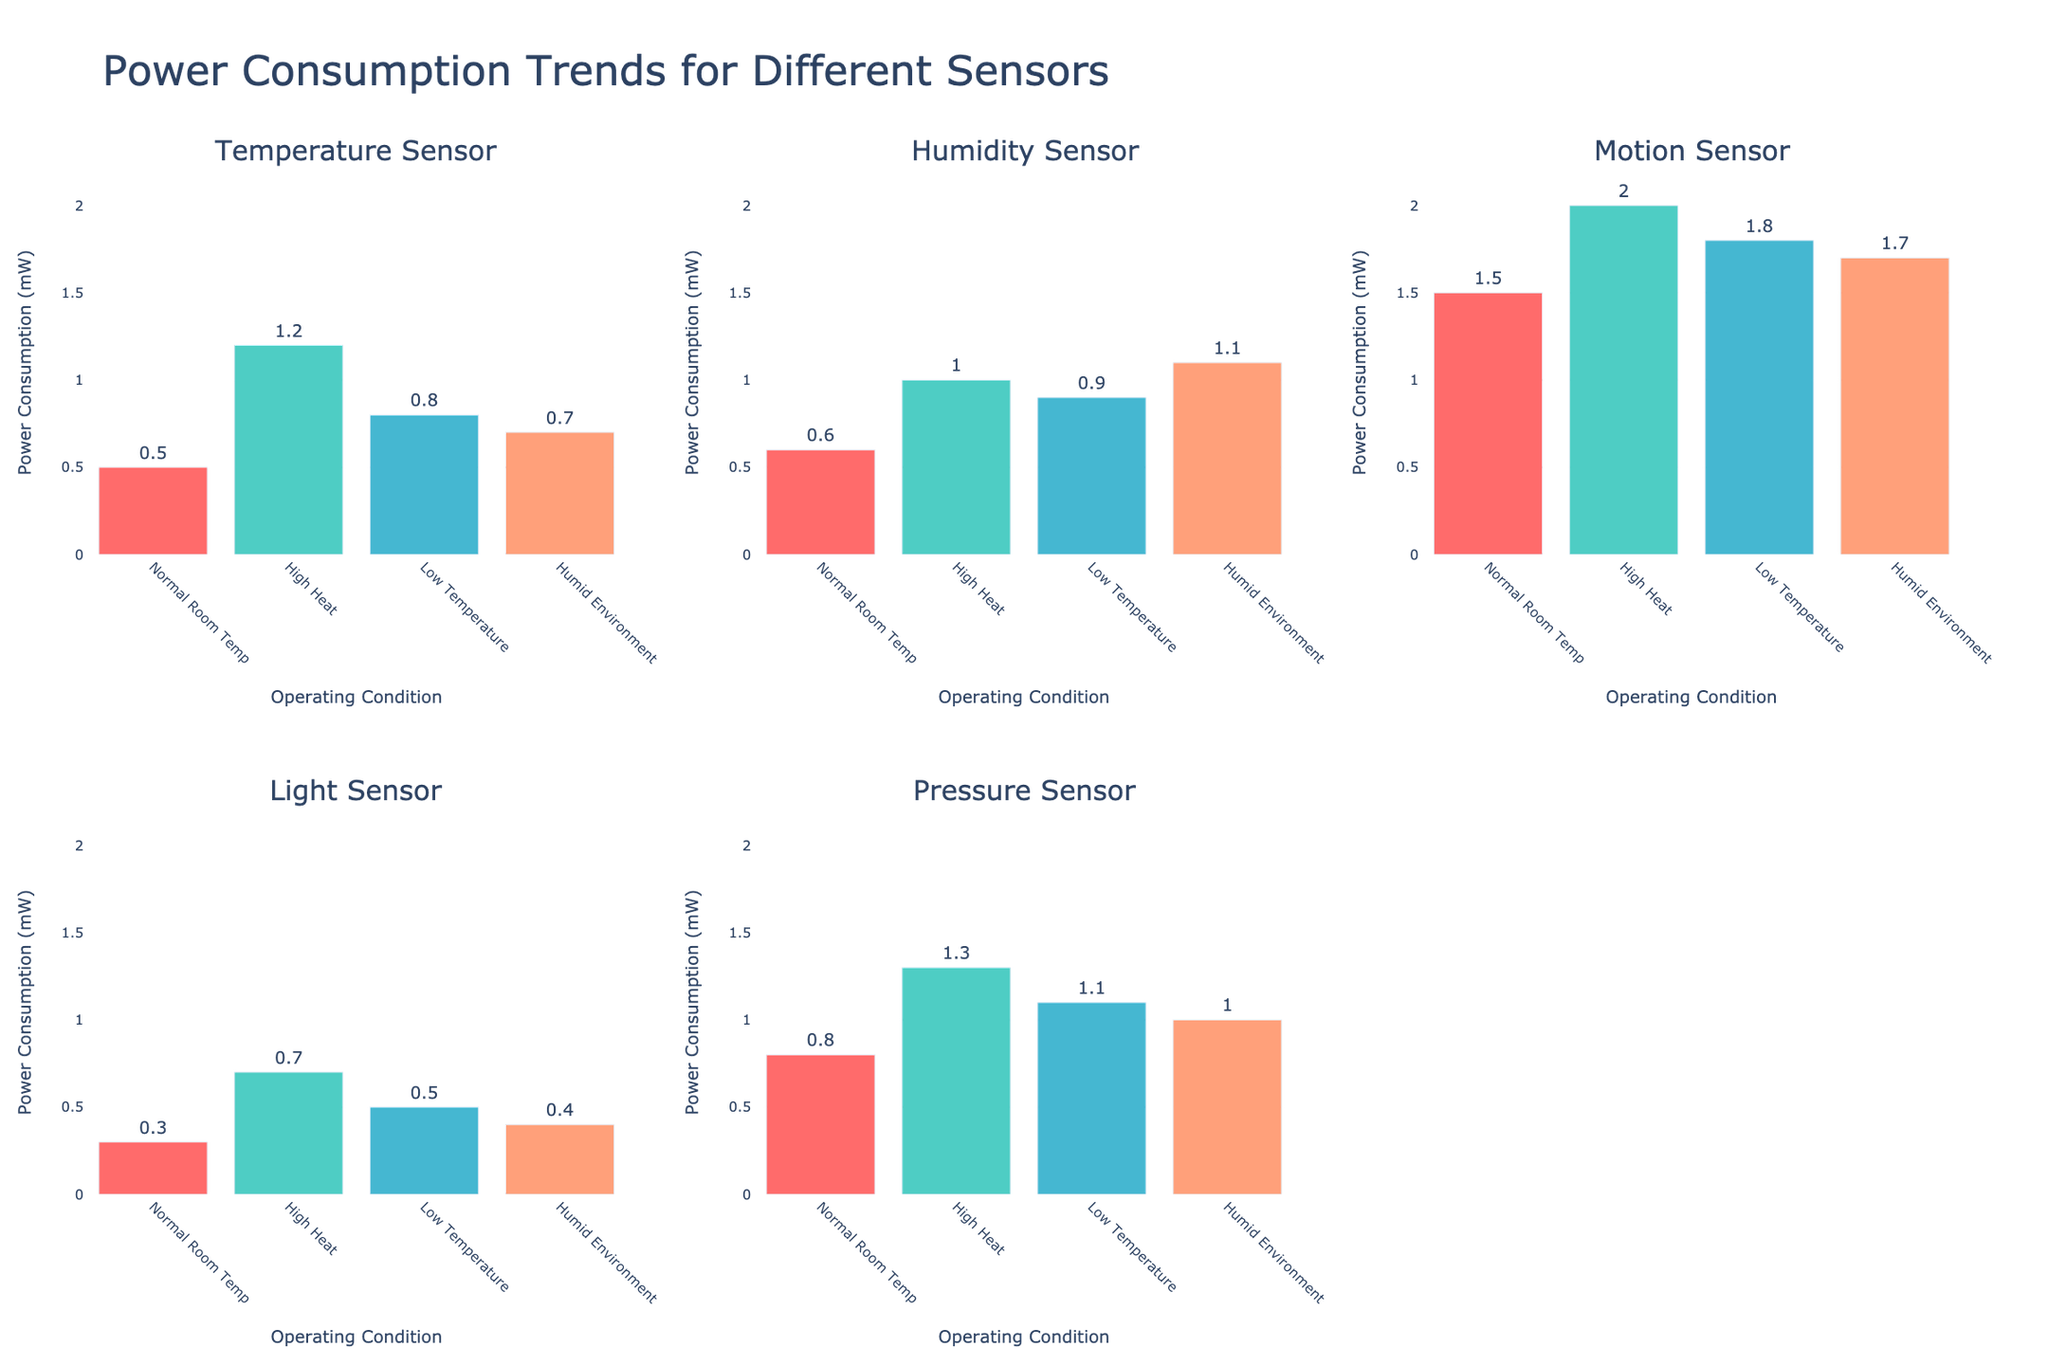What is the title of the chart? The title is prominently displayed at the top of the chart.
Answer: "Power Consumption Trends for Different Sensors" What are the sensor types displayed in the subplots? There are labels for each subplot showing different sensor types. These include Temperature Sensor, Humidity Sensor, Motion Sensor, Light Sensor, and Pressure Sensor.
Answer: Temperature Sensor, Humidity Sensor, Motion Sensor, Light Sensor, Pressure Sensor Which sensor uses the least power in a normal room temperature environment? By looking at the bar heights for the Normal Room Temp condition in each subplot, the Light Sensor has the shortest bar, indicating the lowest power consumption.
Answer: Light Sensor What is the power consumption of the Humidity Sensor in a humid environment? In the subplot for the Humidity Sensor, find the bar labeled "Humid Environment" and read its height or value.
Answer: 1.1 mW Which operating condition leads to the highest power consumption for the Temperature Sensor? Within the Temperature Sensor subplot, compare the heights of the bars for each operating condition. The highest bar corresponds to High Heat.
Answer: High Heat How does the power consumption of the Motion Sensor in high heat compare to normal room temperature? In the Motion Sensor subplot, observe the heights of the bars labeled "High Heat" and "Normal Room Temp" and compare their values.
Answer: 2.0 mW vs. 1.5 mW Rank the operating conditions for the Pressure Sensor from lowest to highest power consumption. Check the bar heights in the Pressure Sensor subplot and order the conditions from the shortest to the tallest bar.
Answer: Normal Room Temp, Humid Environment, Low Temperature, High Heat Which sensor shows the most stable (least variable) power consumption across all operating conditions? Compare the range of bar heights in each subplot. The Light Sensor shows the smallest variation in bar heights across the conditions.
Answer: Light Sensor What is the average power consumption for the Humidity Sensor across all operating conditions? Add the power consumption values for all conditions in the Humidity Sensor subplot and divide by the number of conditions (4). (0.6 + 1.0 + 0.9 + 1.1) / 4 = 0.9 mW.
Answer: 0.9 mW Which sensor has the highest peak power consumption among all sensors? Compare the highest bars in each subplot to identify the tallest one. The Motion Sensor in High Heat has the highest peak at 2.0 mW.
Answer: Motion Sensor 